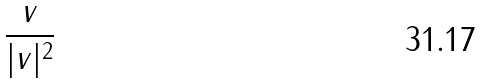<formula> <loc_0><loc_0><loc_500><loc_500>\frac { v } { | v | ^ { 2 } }</formula> 